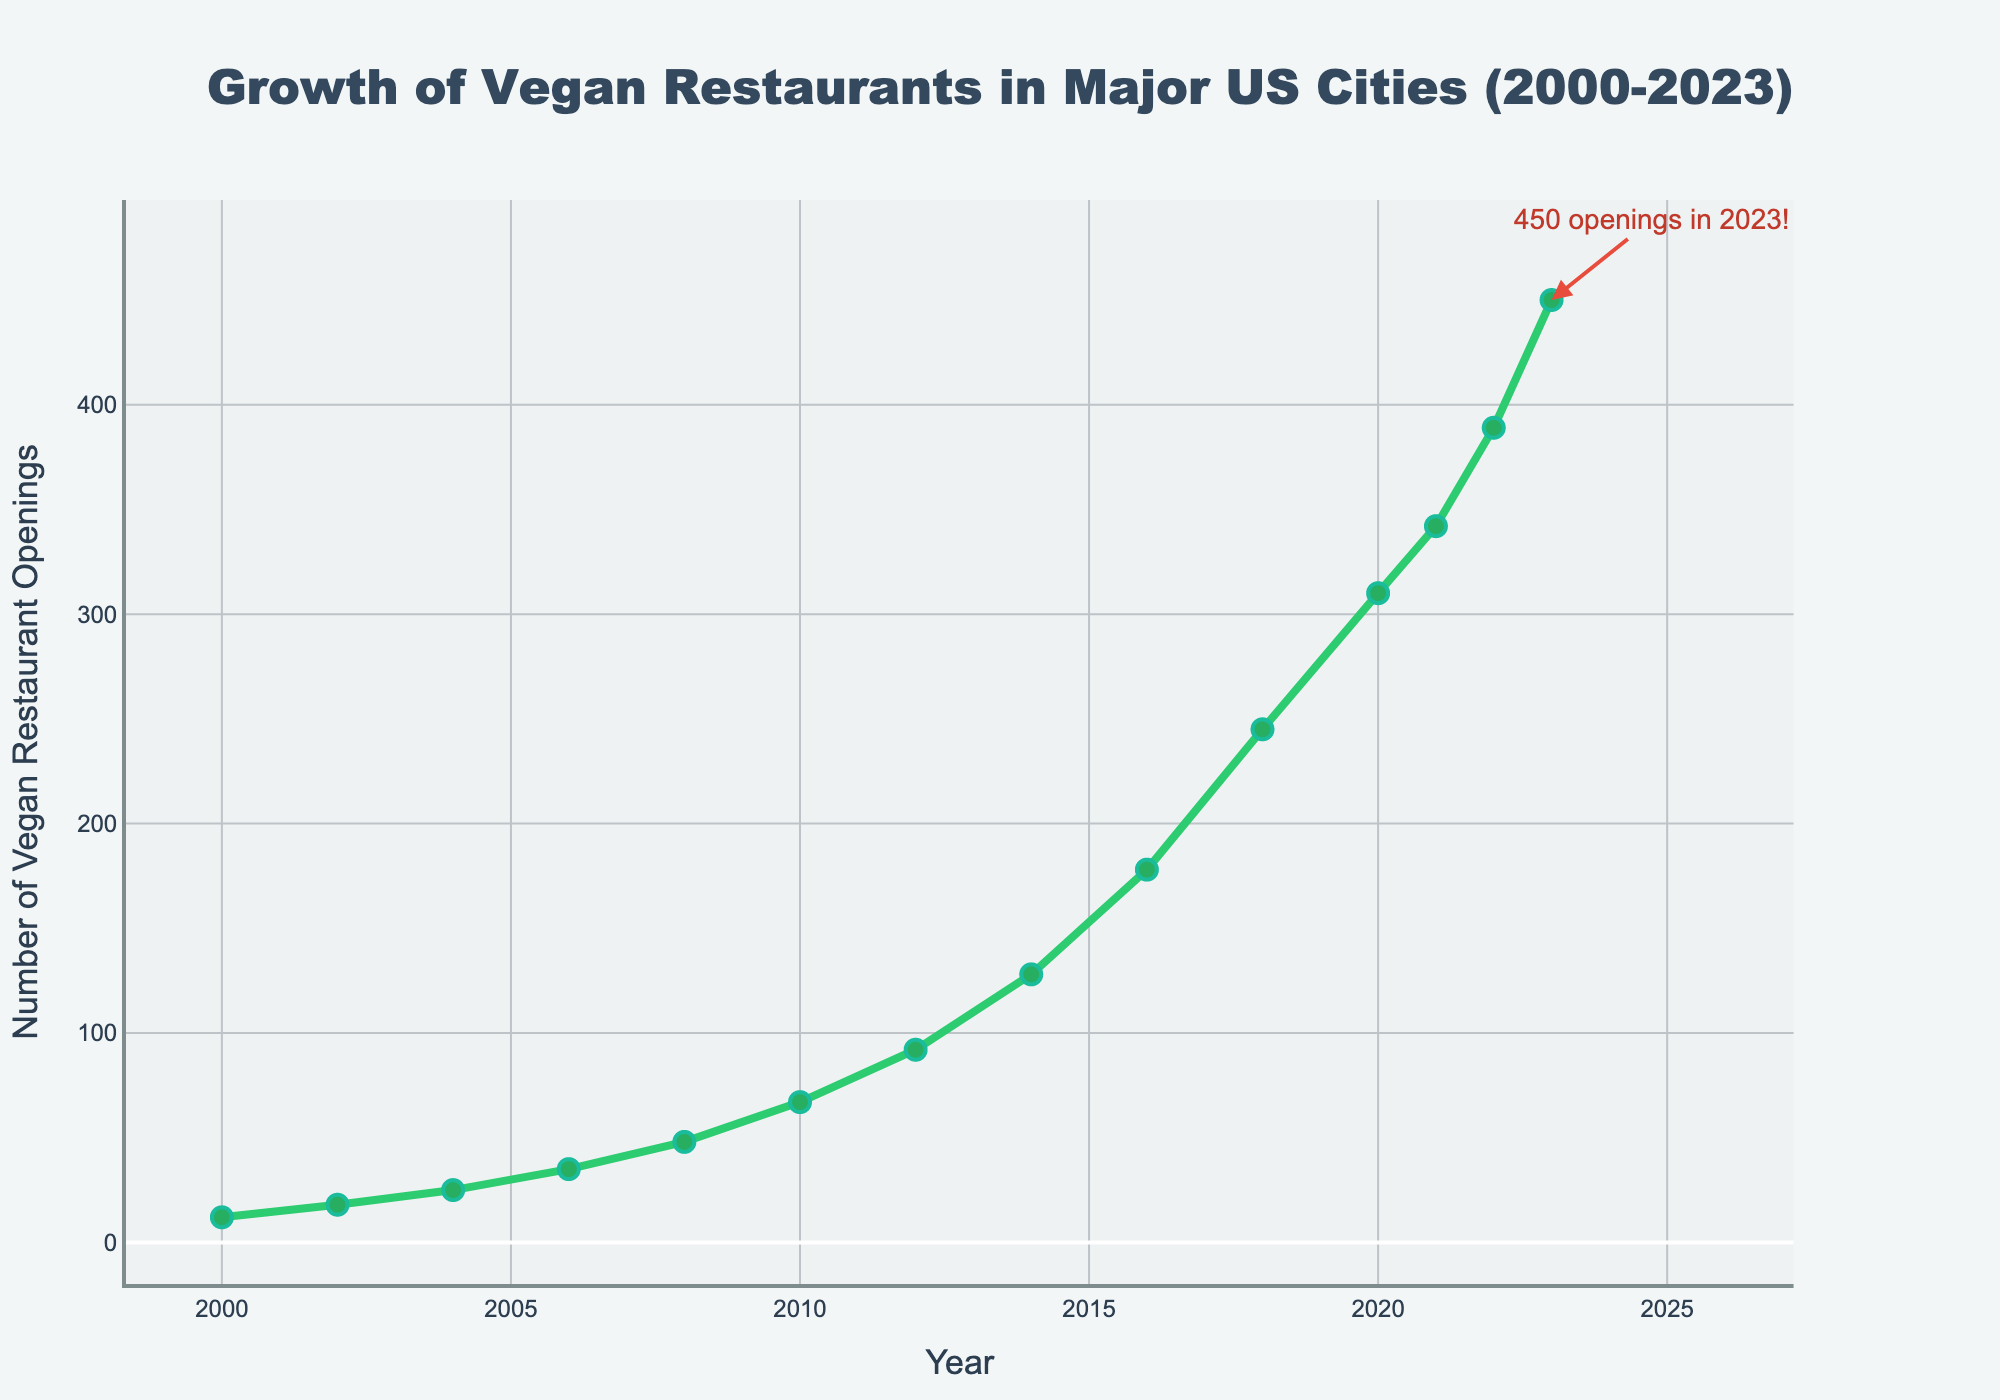When did the most significant increase in the number of vegan restaurant openings occur between consecutive years? The increase can be determined by calculating the difference between openings from each consecutive pair of years and finding the largest difference. From 2022 to 2023, the increase is 450 - 389 = 61, which is the largest difference.
Answer: 2022 to 2023 How long did it take for the number of vegan restaurant openings to more than double from 2008? In 2008, there were 48 restaurant openings. Doubling this is 48 * 2 = 96. We need to find the first year after 2008 where the openings are more than 96. In 2012, there were 92, and in 2014, there were 128, which is more than 96.
Answer: 6 years What is the average number of vegan restaurant openings per year between 2000 and 2010? Compute the sum of openings from 2000 to 2010 and divide by the number of years. (12 + 18 + 25 + 35 + 48 + 67) / 6 = 205 / 6 ≈ 34.17.
Answer: 34.17 How much more were the vegan restaurant openings in 2023 compared to 2012? The openings in 2023 were 450 and in 2012 were 92. Subtract the 2012 value from the 2023 value: 450 - 92 = 358.
Answer: 358 Which year closest to 2010 had a similar number of openings? Check the years close to 2010 for similar numbers. 2010 had 67 openings. 2008 had 48, which is quite lower, and 2012 had 92, closer but slightly higher. So 2012 is the year closest to 2010 with a similar number of openings.
Answer: 2012 In which year did the number of vegan restaurant openings first exceed 200? Examine the data to find the first year with openings exceeding 200. In 2016, there were 178, and in 2018, there were 245, so 2018 is the first year exceeding 200.
Answer: 2018 What is the median number of vegan restaurant openings for the years 2000, 2004, 2008, 2012, and 2016? List the opening numbers for these years: (12, 25, 48, 92, 178). The median is the middle value in an ordered list, so the median is 48.
Answer: 48 Which year had the smallest increase in vegan restaurant openings compared to the previous year? Calculate the differences year over year and determine the smallest positive difference. The smallest difference is from 2021 to 2022: 389 - 342 = 47.
Answer: 2021 to 2022 Between which consecutive years did the number of restaurant openings increase by more than 100 for the first time? Check each consecutive pair of years for an increase greater than 100. From 2014 to 2016, the number of openings increased from 128 to 178, a difference of 50. From 2016 to 2018, it increased from 178 to 245, a difference of 67. From 2018 to 2020, the increase was from 245 to 310, which is 65. None yet increase by 100 until 2020 to 2021, with an increase from 310 to 342, just 32.
Answer: None over 100 